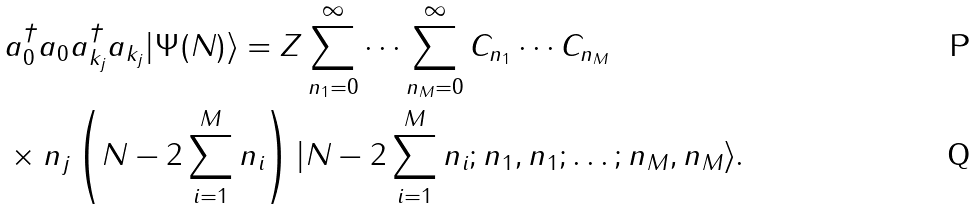Convert formula to latex. <formula><loc_0><loc_0><loc_500><loc_500>& a _ { 0 } ^ { \dagger } a _ { 0 } a _ { { k } _ { j } } ^ { \dagger } a _ { { k } _ { j } } | \Psi ( N ) \rangle = Z \sum _ { n _ { 1 } = 0 } ^ { \infty } \cdots \sum _ { n _ { M } = 0 } ^ { \infty } C _ { n _ { 1 } } \cdots C _ { n _ { M } } \\ & \times n _ { j } \left ( N - 2 \sum _ { i = 1 } ^ { M } n _ { i } \right ) | N - 2 \sum _ { i = 1 } ^ { M } n _ { i } ; n _ { 1 } , n _ { 1 } ; \dots ; n _ { M } , n _ { M } \rangle .</formula> 